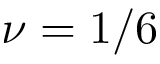Convert formula to latex. <formula><loc_0><loc_0><loc_500><loc_500>\nu = 1 / 6</formula> 